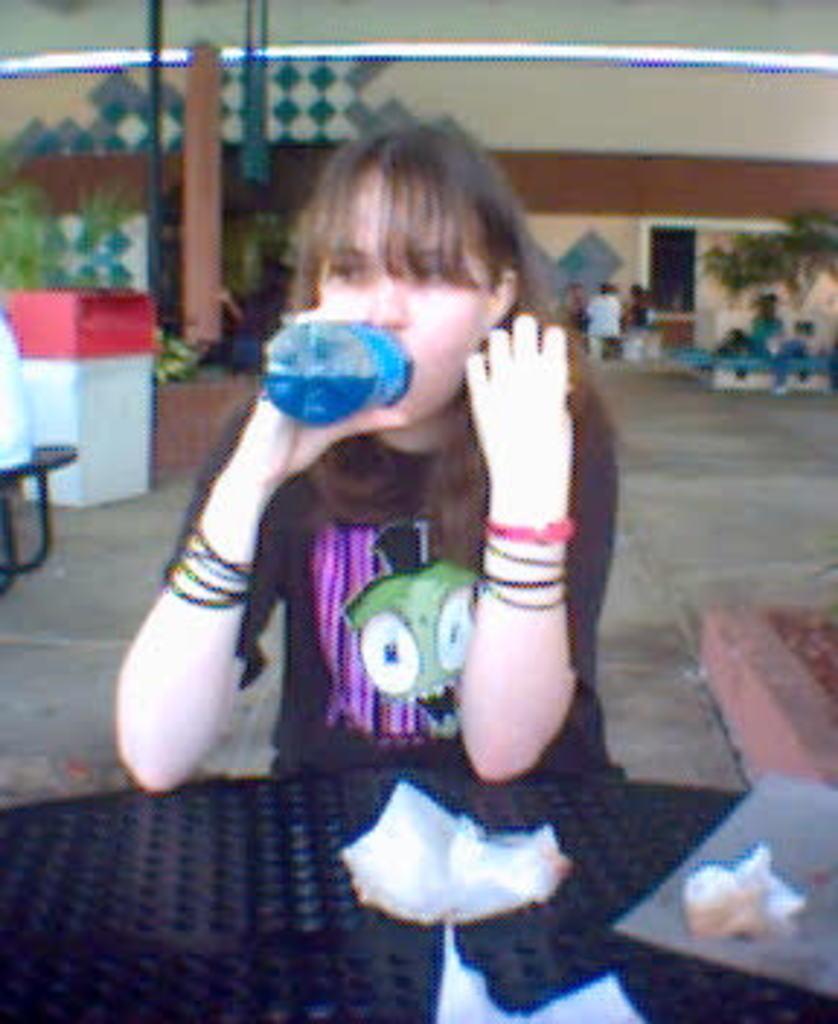In one or two sentences, can you explain what this image depicts? A woman is sitting at a table and drinking with a bottle in her hand. 